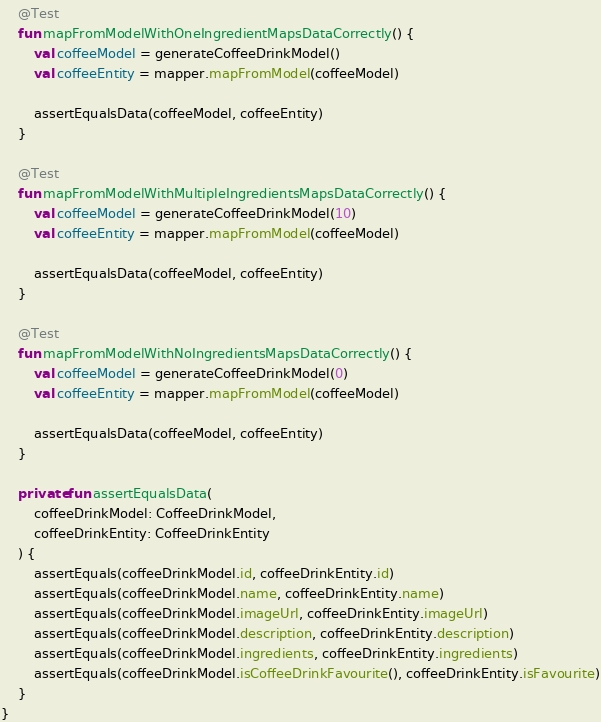<code> <loc_0><loc_0><loc_500><loc_500><_Kotlin_>
    @Test
    fun mapFromModelWithOneIngredientMapsDataCorrectly() {
        val coffeeModel = generateCoffeeDrinkModel()
        val coffeeEntity = mapper.mapFromModel(coffeeModel)

        assertEqualsData(coffeeModel, coffeeEntity)
    }

    @Test
    fun mapFromModelWithMultipleIngredientsMapsDataCorrectly() {
        val coffeeModel = generateCoffeeDrinkModel(10)
        val coffeeEntity = mapper.mapFromModel(coffeeModel)

        assertEqualsData(coffeeModel, coffeeEntity)
    }

    @Test
    fun mapFromModelWithNoIngredientsMapsDataCorrectly() {
        val coffeeModel = generateCoffeeDrinkModel(0)
        val coffeeEntity = mapper.mapFromModel(coffeeModel)

        assertEqualsData(coffeeModel, coffeeEntity)
    }

    private fun assertEqualsData(
        coffeeDrinkModel: CoffeeDrinkModel,
        coffeeDrinkEntity: CoffeeDrinkEntity
    ) {
        assertEquals(coffeeDrinkModel.id, coffeeDrinkEntity.id)
        assertEquals(coffeeDrinkModel.name, coffeeDrinkEntity.name)
        assertEquals(coffeeDrinkModel.imageUrl, coffeeDrinkEntity.imageUrl)
        assertEquals(coffeeDrinkModel.description, coffeeDrinkEntity.description)
        assertEquals(coffeeDrinkModel.ingredients, coffeeDrinkEntity.ingredients)
        assertEquals(coffeeDrinkModel.isCoffeeDrinkFavourite(), coffeeDrinkEntity.isFavourite)
    }
}</code> 